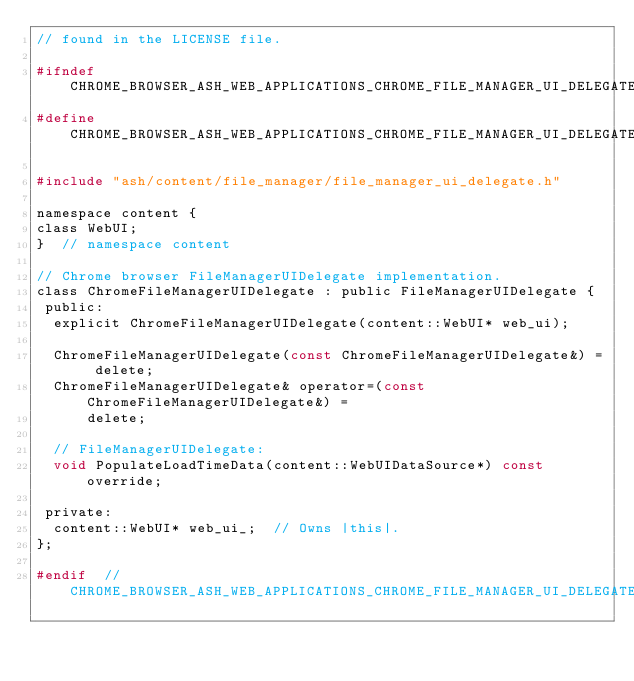Convert code to text. <code><loc_0><loc_0><loc_500><loc_500><_C_>// found in the LICENSE file.

#ifndef CHROME_BROWSER_ASH_WEB_APPLICATIONS_CHROME_FILE_MANAGER_UI_DELEGATE_H_
#define CHROME_BROWSER_ASH_WEB_APPLICATIONS_CHROME_FILE_MANAGER_UI_DELEGATE_H_

#include "ash/content/file_manager/file_manager_ui_delegate.h"

namespace content {
class WebUI;
}  // namespace content

// Chrome browser FileManagerUIDelegate implementation.
class ChromeFileManagerUIDelegate : public FileManagerUIDelegate {
 public:
  explicit ChromeFileManagerUIDelegate(content::WebUI* web_ui);

  ChromeFileManagerUIDelegate(const ChromeFileManagerUIDelegate&) = delete;
  ChromeFileManagerUIDelegate& operator=(const ChromeFileManagerUIDelegate&) =
      delete;

  // FileManagerUIDelegate:
  void PopulateLoadTimeData(content::WebUIDataSource*) const override;

 private:
  content::WebUI* web_ui_;  // Owns |this|.
};

#endif  // CHROME_BROWSER_ASH_WEB_APPLICATIONS_CHROME_FILE_MANAGER_UI_DELEGATE_H_
</code> 